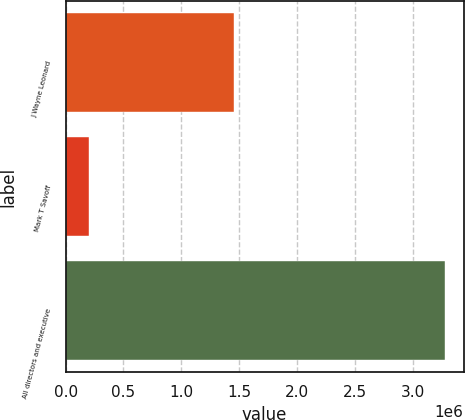Convert chart to OTSL. <chart><loc_0><loc_0><loc_500><loc_500><bar_chart><fcel>J Wayne Leonard<fcel>Mark T Savoff<fcel>All directors and executive<nl><fcel>1.45853e+06<fcel>199467<fcel>3.27344e+06<nl></chart> 